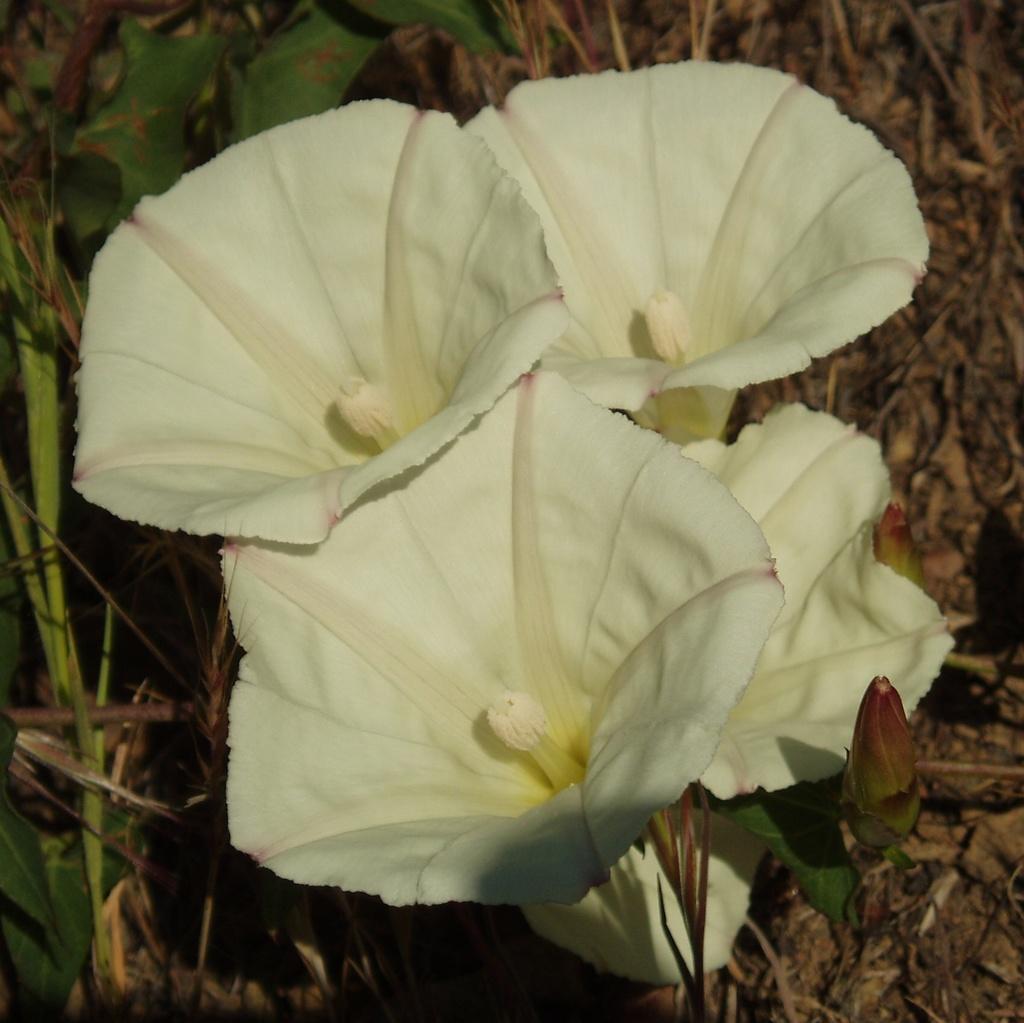Could you give a brief overview of what you see in this image? In the image we can see in front there are flowers which are in white colour and behind there are plants. 